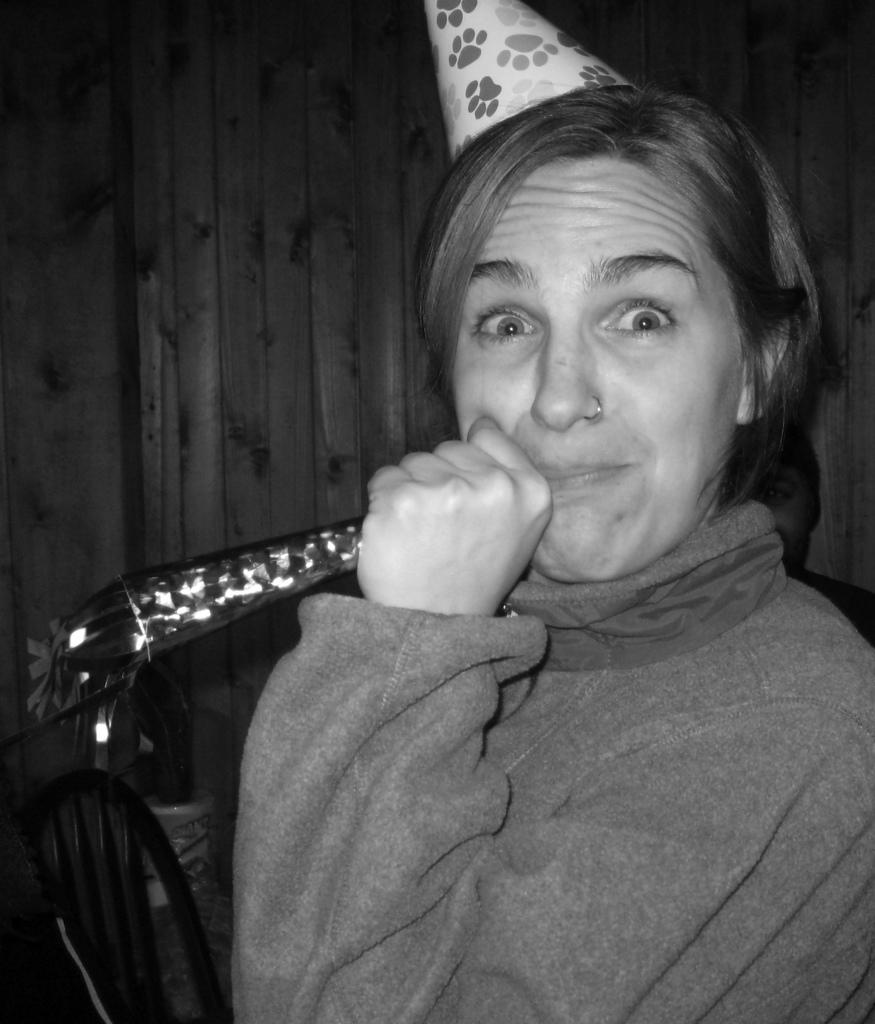Who is present in the image? There is a woman in the image. What is the woman wearing on her upper body? The woman is wearing a sweater. What type of headwear is the woman wearing? The woman is wearing a cap. What can be seen on the left side of the image? There is a chair on the left side of the image. What color scheme is used in the image? The image is in black and white color. Can you see a snake slithering around the woman's feet in the image? No, there is no snake present in the image. What type of oatmeal is the woman eating in the image? There is no oatmeal visible in the image. 